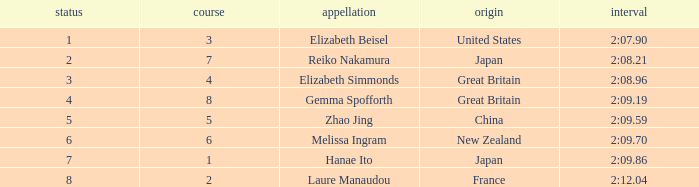What is Laure Manaudou's highest rank? 8.0. 